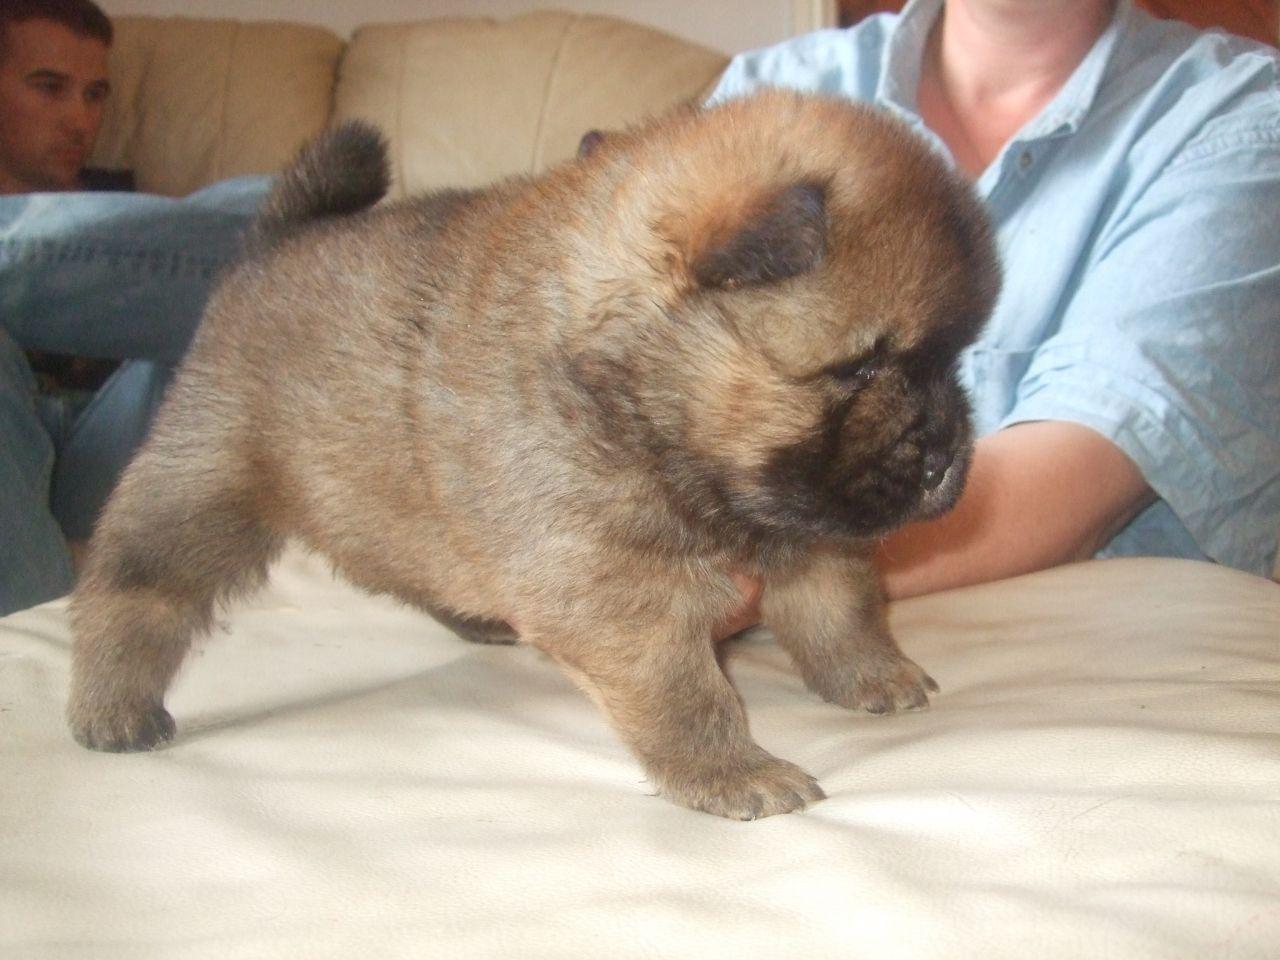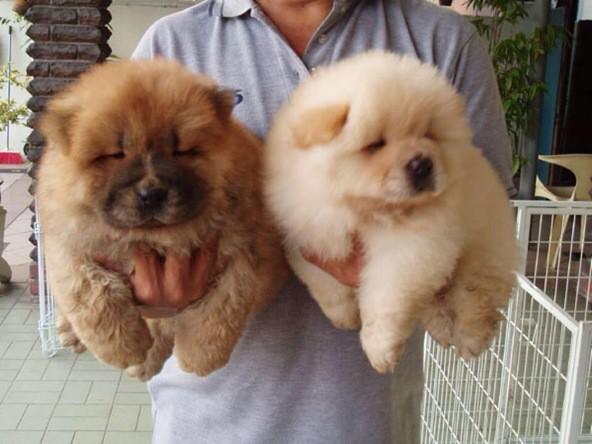The first image is the image on the left, the second image is the image on the right. Considering the images on both sides, is "There is one human head in the image on the left." valid? Answer yes or no. Yes. 